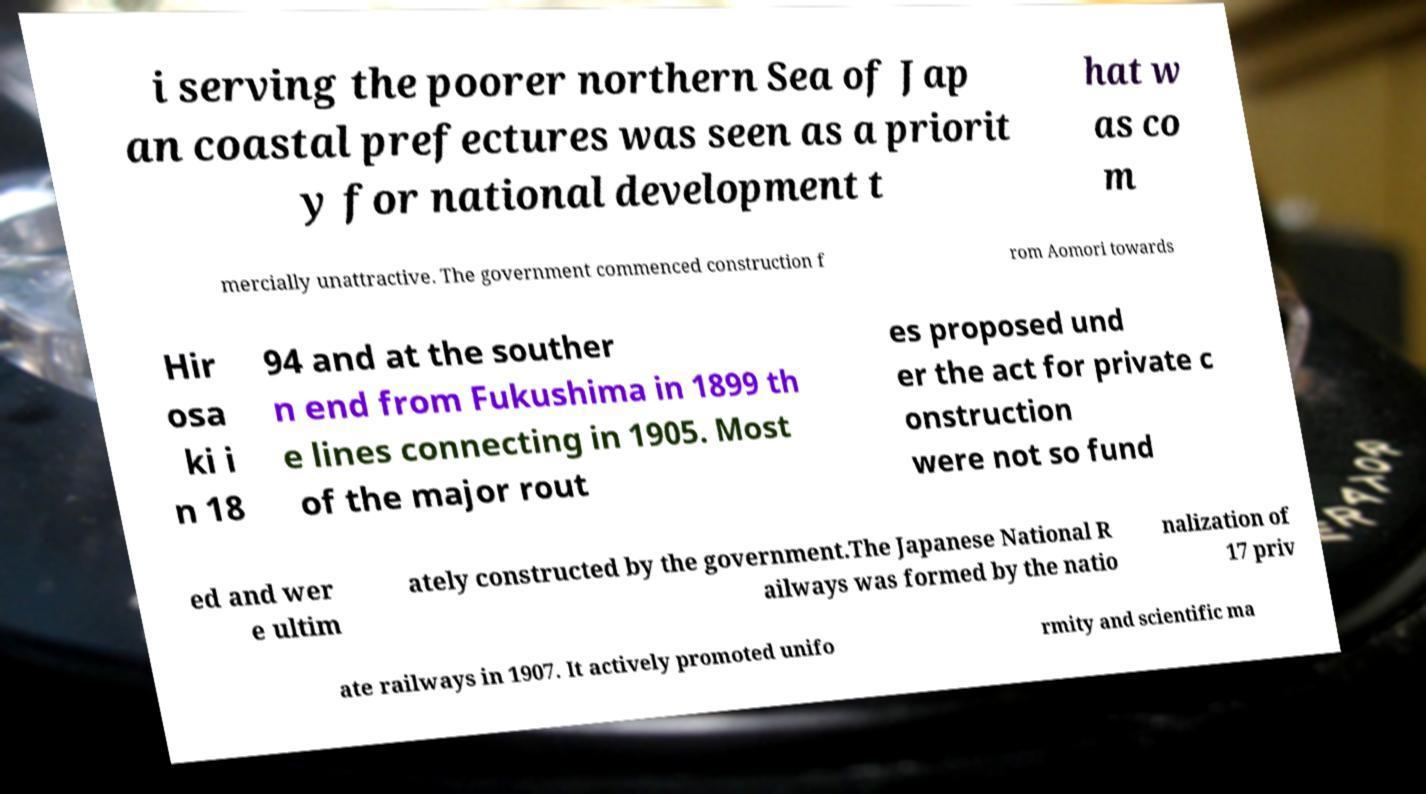Can you read and provide the text displayed in the image?This photo seems to have some interesting text. Can you extract and type it out for me? i serving the poorer northern Sea of Jap an coastal prefectures was seen as a priorit y for national development t hat w as co m mercially unattractive. The government commenced construction f rom Aomori towards Hir osa ki i n 18 94 and at the souther n end from Fukushima in 1899 th e lines connecting in 1905. Most of the major rout es proposed und er the act for private c onstruction were not so fund ed and wer e ultim ately constructed by the government.The Japanese National R ailways was formed by the natio nalization of 17 priv ate railways in 1907. It actively promoted unifo rmity and scientific ma 